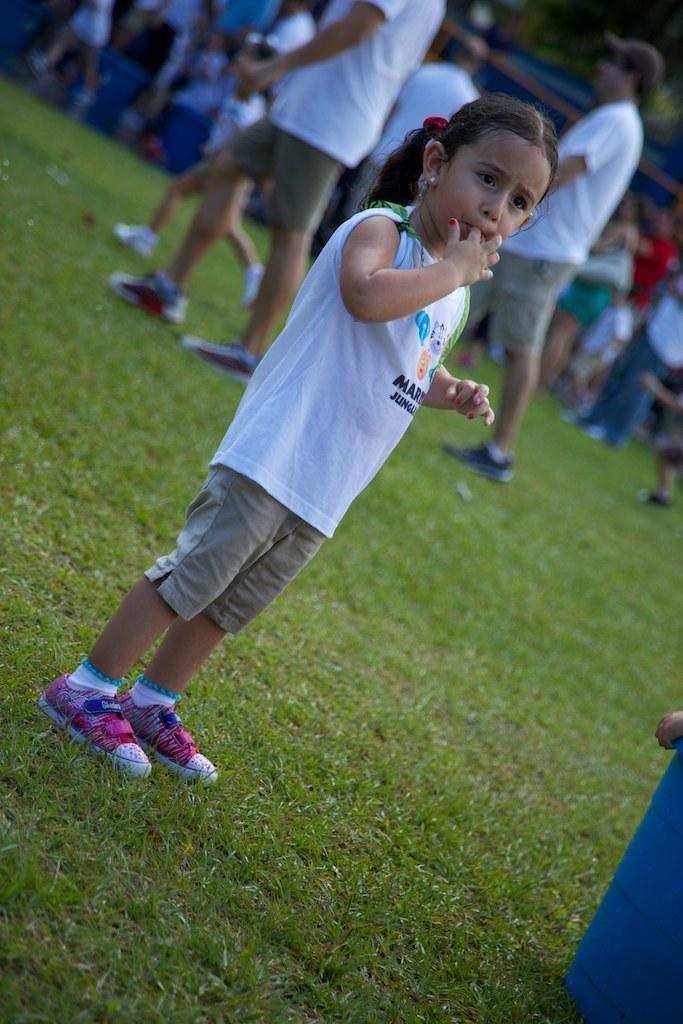Please provide a concise description of this image. In this picture I can see people are standing on the ground. Here I can see a girl is standing. The girl is wearing white color t-shirt, shorts and shoes. Here I can see the grass. 